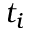Convert formula to latex. <formula><loc_0><loc_0><loc_500><loc_500>t _ { i }</formula> 